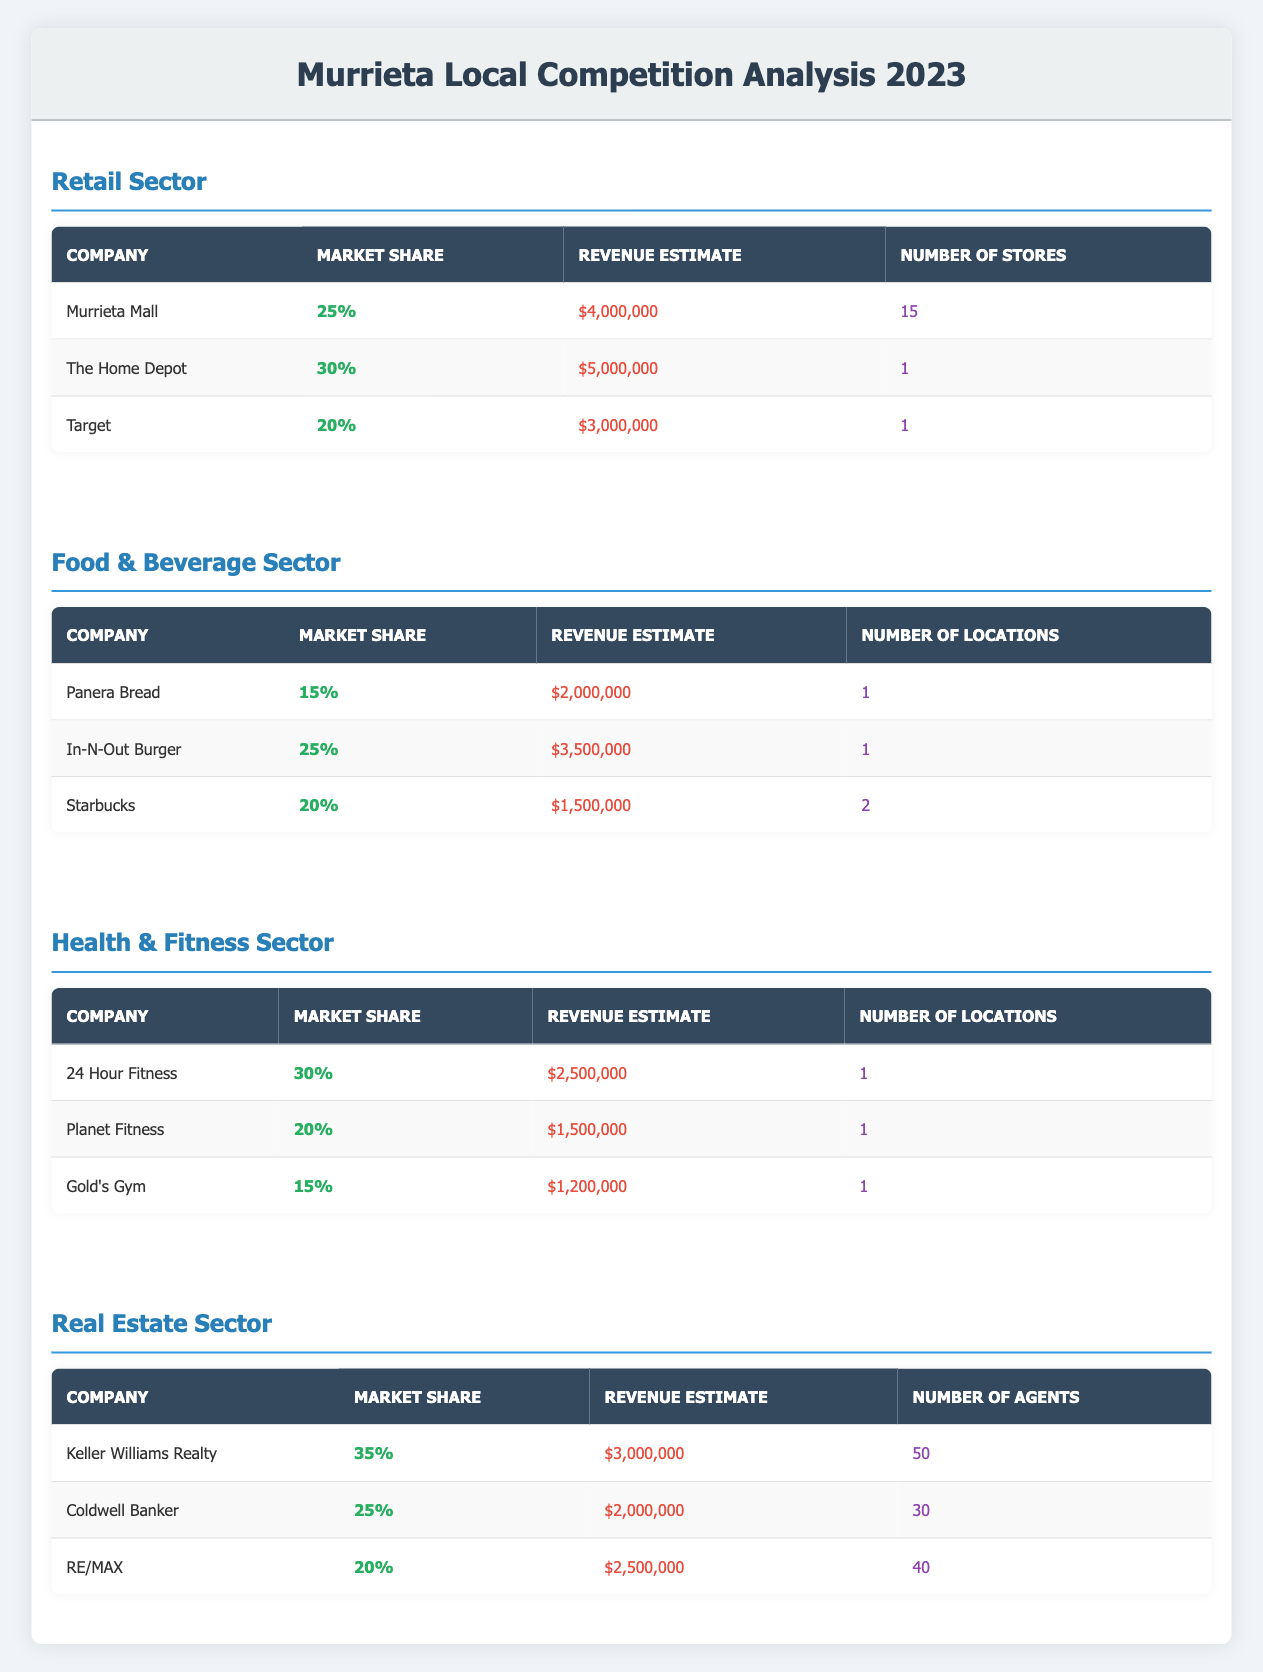What is the market share of The Home Depot in the retail sector? The market share for The Home Depot is listed in the table under the retail sector, which shows it as 30%.
Answer: 30% Which company has the highest market share in the real estate sector? The table shows Keller Williams Realty with a market share of 35%, which is higher than the other competitors listed.
Answer: Keller Williams Realty Calculate the total estimated revenue of the Food & Beverage sector competitors. The revenue estimates for the Food & Beverage sector competitors are as follows: $2,000,000 (Panera Bread) + $3,500,000 (In-N-Out Burger) + $1,500,000 (Starbucks) = $7,000,000.
Answer: $7,000,000 Is Starbucks the lowest-revenue company in the Food & Beverage sector? Looking at the revenue estimates for Food & Beverage sector competitors, Starbucks has $1,500,000, which is indeed lower than Panera Bread ($2,000,000) and In-N-Out Burger ($3,500,000).
Answer: Yes What is the average number of locations per competitor in the Health & Fitness sector? The competitors in the Health & Fitness sector have the following number of locations: 1 (24 Hour Fitness) + 1 (Planet Fitness) + 1 (Gold's Gym) = 3 total locations. Dividing by the 3 competitors yields an average of 3/3 = 1 location.
Answer: 1 